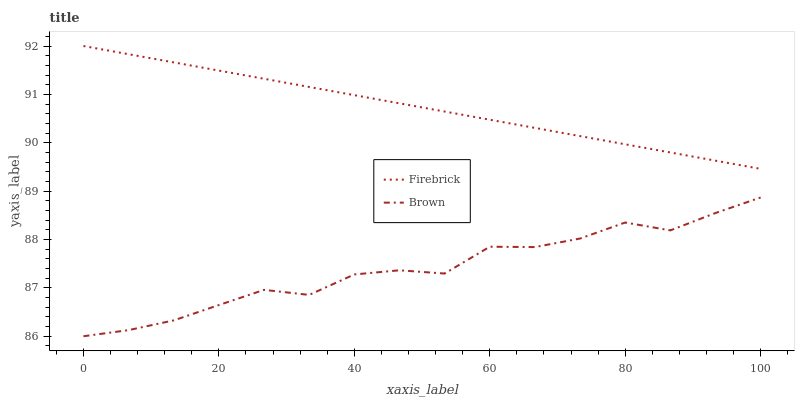Does Firebrick have the minimum area under the curve?
Answer yes or no. No. Is Firebrick the roughest?
Answer yes or no. No. Does Firebrick have the lowest value?
Answer yes or no. No. Is Brown less than Firebrick?
Answer yes or no. Yes. Is Firebrick greater than Brown?
Answer yes or no. Yes. Does Brown intersect Firebrick?
Answer yes or no. No. 